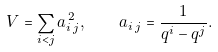Convert formula to latex. <formula><loc_0><loc_0><loc_500><loc_500>V = \sum _ { i < j } a _ { i \, j } ^ { \, 2 } , \quad a _ { i \, j } = \frac { 1 } { q ^ { i } - q ^ { j } } .</formula> 